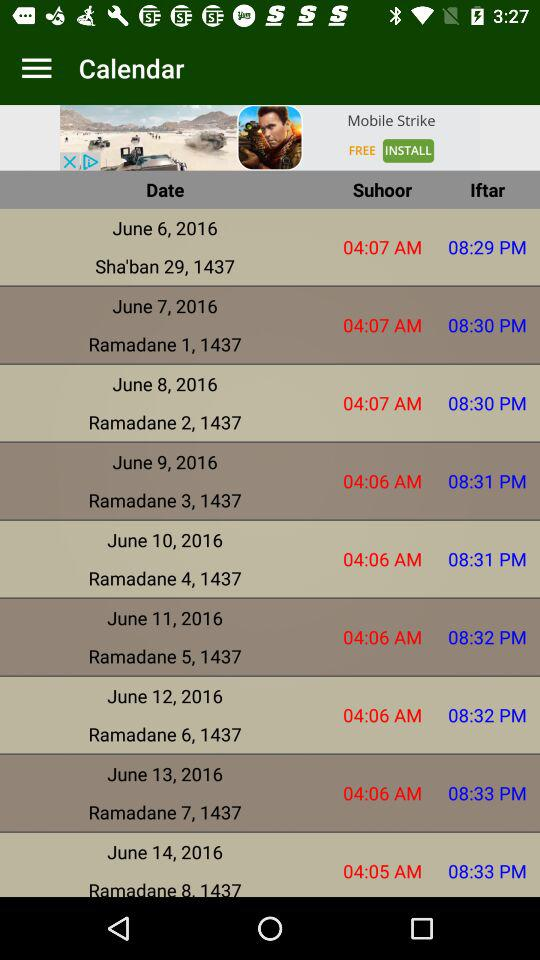What is the suhoor time for "Ramadane 5, 1437"? The time is 04:06 AM. 